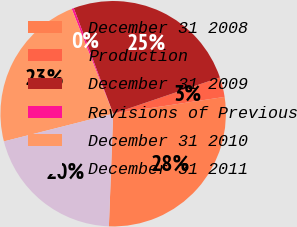Convert chart to OTSL. <chart><loc_0><loc_0><loc_500><loc_500><pie_chart><fcel>December 31 2008<fcel>Production<fcel>December 31 2009<fcel>Revisions of Previous<fcel>December 31 2010<fcel>December 31 2011<nl><fcel>27.99%<fcel>2.83%<fcel>25.47%<fcel>0.31%<fcel>22.96%<fcel>20.45%<nl></chart> 